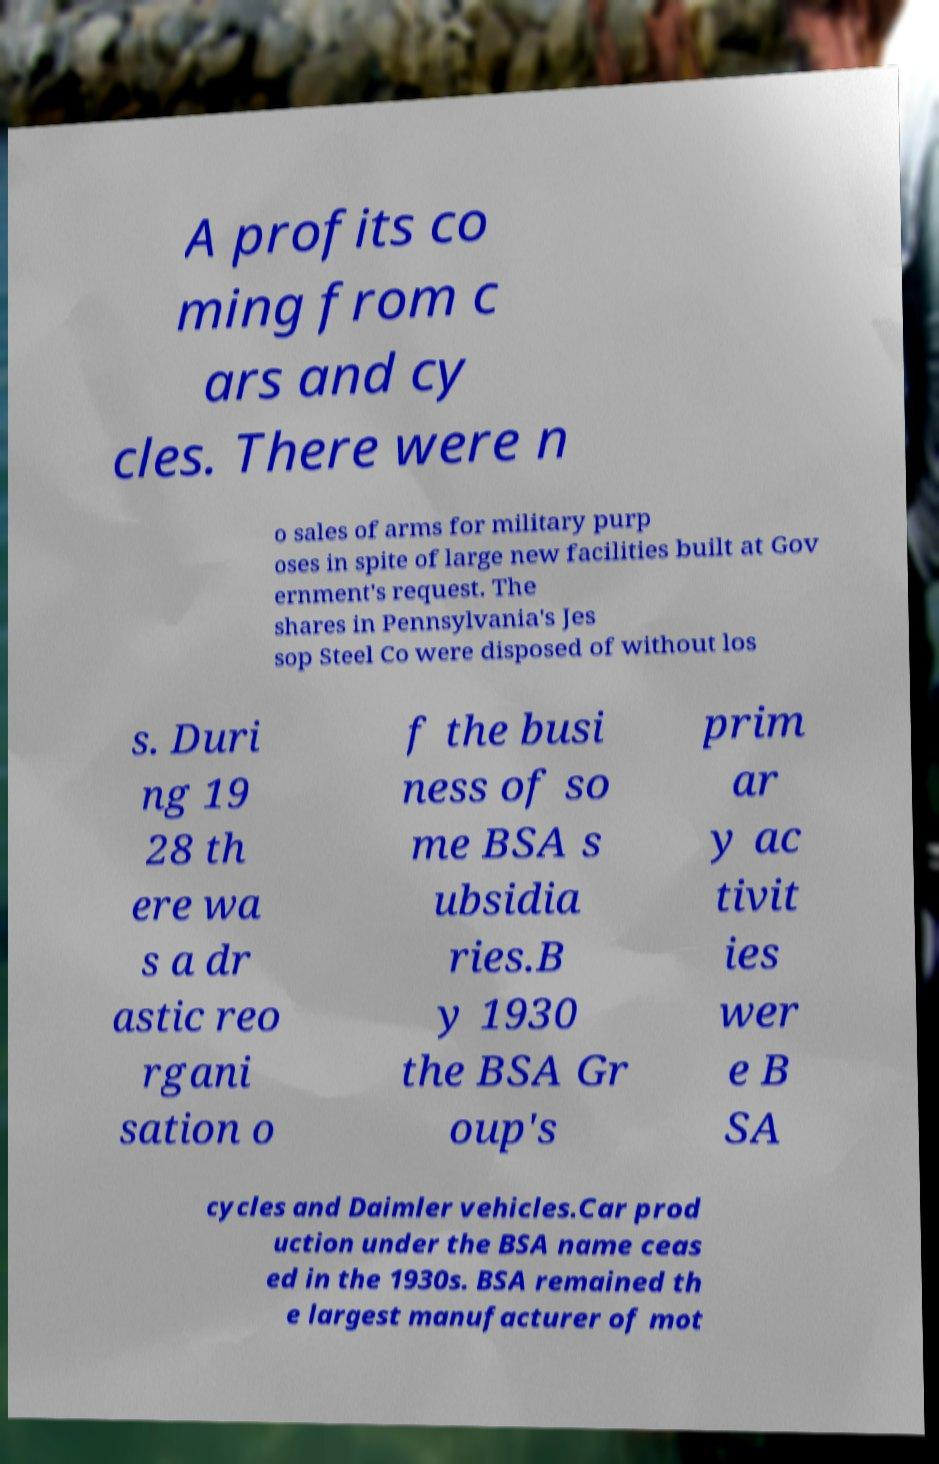There's text embedded in this image that I need extracted. Can you transcribe it verbatim? A profits co ming from c ars and cy cles. There were n o sales of arms for military purp oses in spite of large new facilities built at Gov ernment's request. The shares in Pennsylvania's Jes sop Steel Co were disposed of without los s. Duri ng 19 28 th ere wa s a dr astic reo rgani sation o f the busi ness of so me BSA s ubsidia ries.B y 1930 the BSA Gr oup's prim ar y ac tivit ies wer e B SA cycles and Daimler vehicles.Car prod uction under the BSA name ceas ed in the 1930s. BSA remained th e largest manufacturer of mot 